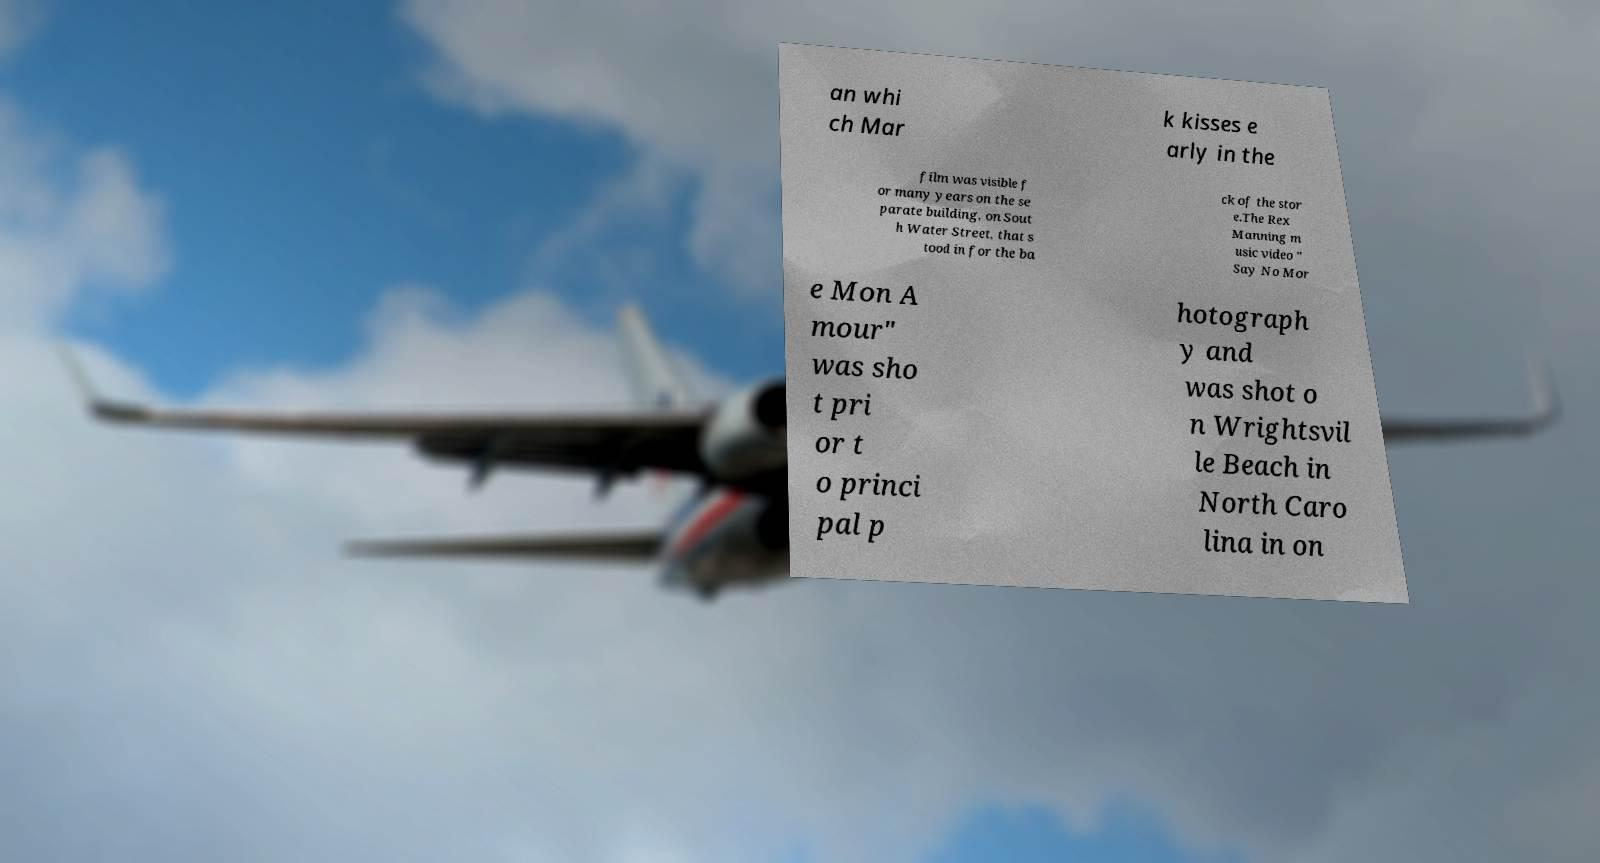Can you read and provide the text displayed in the image?This photo seems to have some interesting text. Can you extract and type it out for me? an whi ch Mar k kisses e arly in the film was visible f or many years on the se parate building, on Sout h Water Street, that s tood in for the ba ck of the stor e.The Rex Manning m usic video " Say No Mor e Mon A mour" was sho t pri or t o princi pal p hotograph y and was shot o n Wrightsvil le Beach in North Caro lina in on 